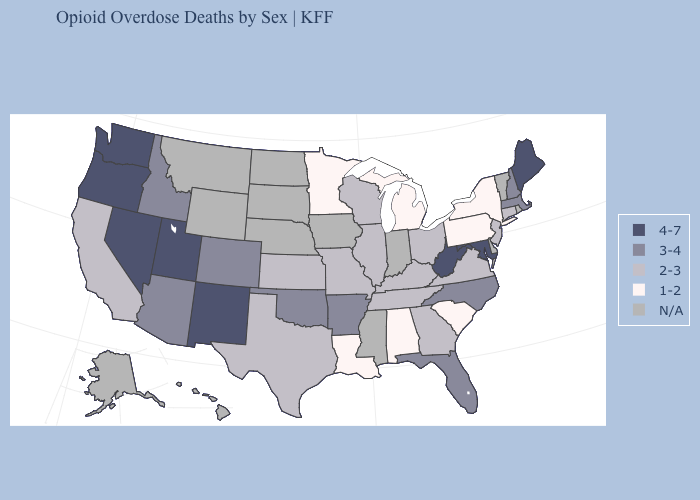What is the highest value in the USA?
Write a very short answer. 4-7. How many symbols are there in the legend?
Keep it brief. 5. Which states have the lowest value in the Northeast?
Write a very short answer. New York, Pennsylvania. Does Oregon have the highest value in the USA?
Keep it brief. Yes. What is the value of Tennessee?
Short answer required. 2-3. Among the states that border North Carolina , does South Carolina have the lowest value?
Be succinct. Yes. What is the value of Nevada?
Quick response, please. 4-7. Name the states that have a value in the range 2-3?
Answer briefly. California, Connecticut, Georgia, Illinois, Kansas, Kentucky, Missouri, New Jersey, Ohio, Tennessee, Texas, Virginia, Wisconsin. What is the highest value in the Northeast ?
Short answer required. 4-7. How many symbols are there in the legend?
Answer briefly. 5. Which states have the lowest value in the West?
Give a very brief answer. California. What is the value of Illinois?
Be succinct. 2-3. Name the states that have a value in the range 2-3?
Concise answer only. California, Connecticut, Georgia, Illinois, Kansas, Kentucky, Missouri, New Jersey, Ohio, Tennessee, Texas, Virginia, Wisconsin. Among the states that border Wyoming , which have the lowest value?
Be succinct. Colorado, Idaho. 